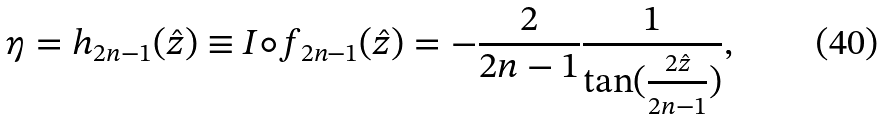<formula> <loc_0><loc_0><loc_500><loc_500>\eta = h _ { 2 n - 1 } ( \hat { z } ) \equiv I \circ f _ { 2 n - 1 } ( \hat { z } ) = - \frac { 2 } { 2 n - 1 } \frac { 1 } { \tan ( \frac { 2 \hat { z } } { 2 n - 1 } ) } ,</formula> 